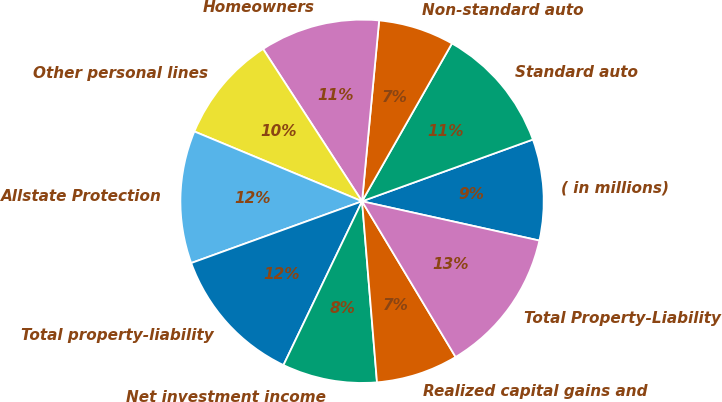Convert chart to OTSL. <chart><loc_0><loc_0><loc_500><loc_500><pie_chart><fcel>( in millions)<fcel>Standard auto<fcel>Non-standard auto<fcel>Homeowners<fcel>Other personal lines<fcel>Allstate Protection<fcel>Total property-liability<fcel>Net investment income<fcel>Realized capital gains and<fcel>Total Property-Liability<nl><fcel>8.99%<fcel>11.24%<fcel>6.74%<fcel>10.67%<fcel>9.55%<fcel>11.8%<fcel>12.36%<fcel>8.43%<fcel>7.3%<fcel>12.92%<nl></chart> 